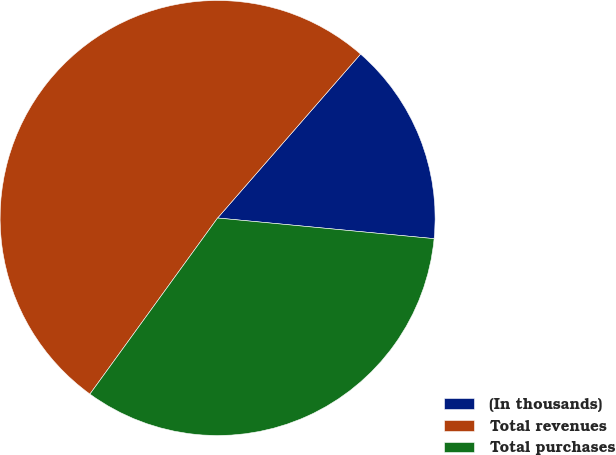<chart> <loc_0><loc_0><loc_500><loc_500><pie_chart><fcel>(In thousands)<fcel>Total revenues<fcel>Total purchases<nl><fcel>15.1%<fcel>51.43%<fcel>33.47%<nl></chart> 